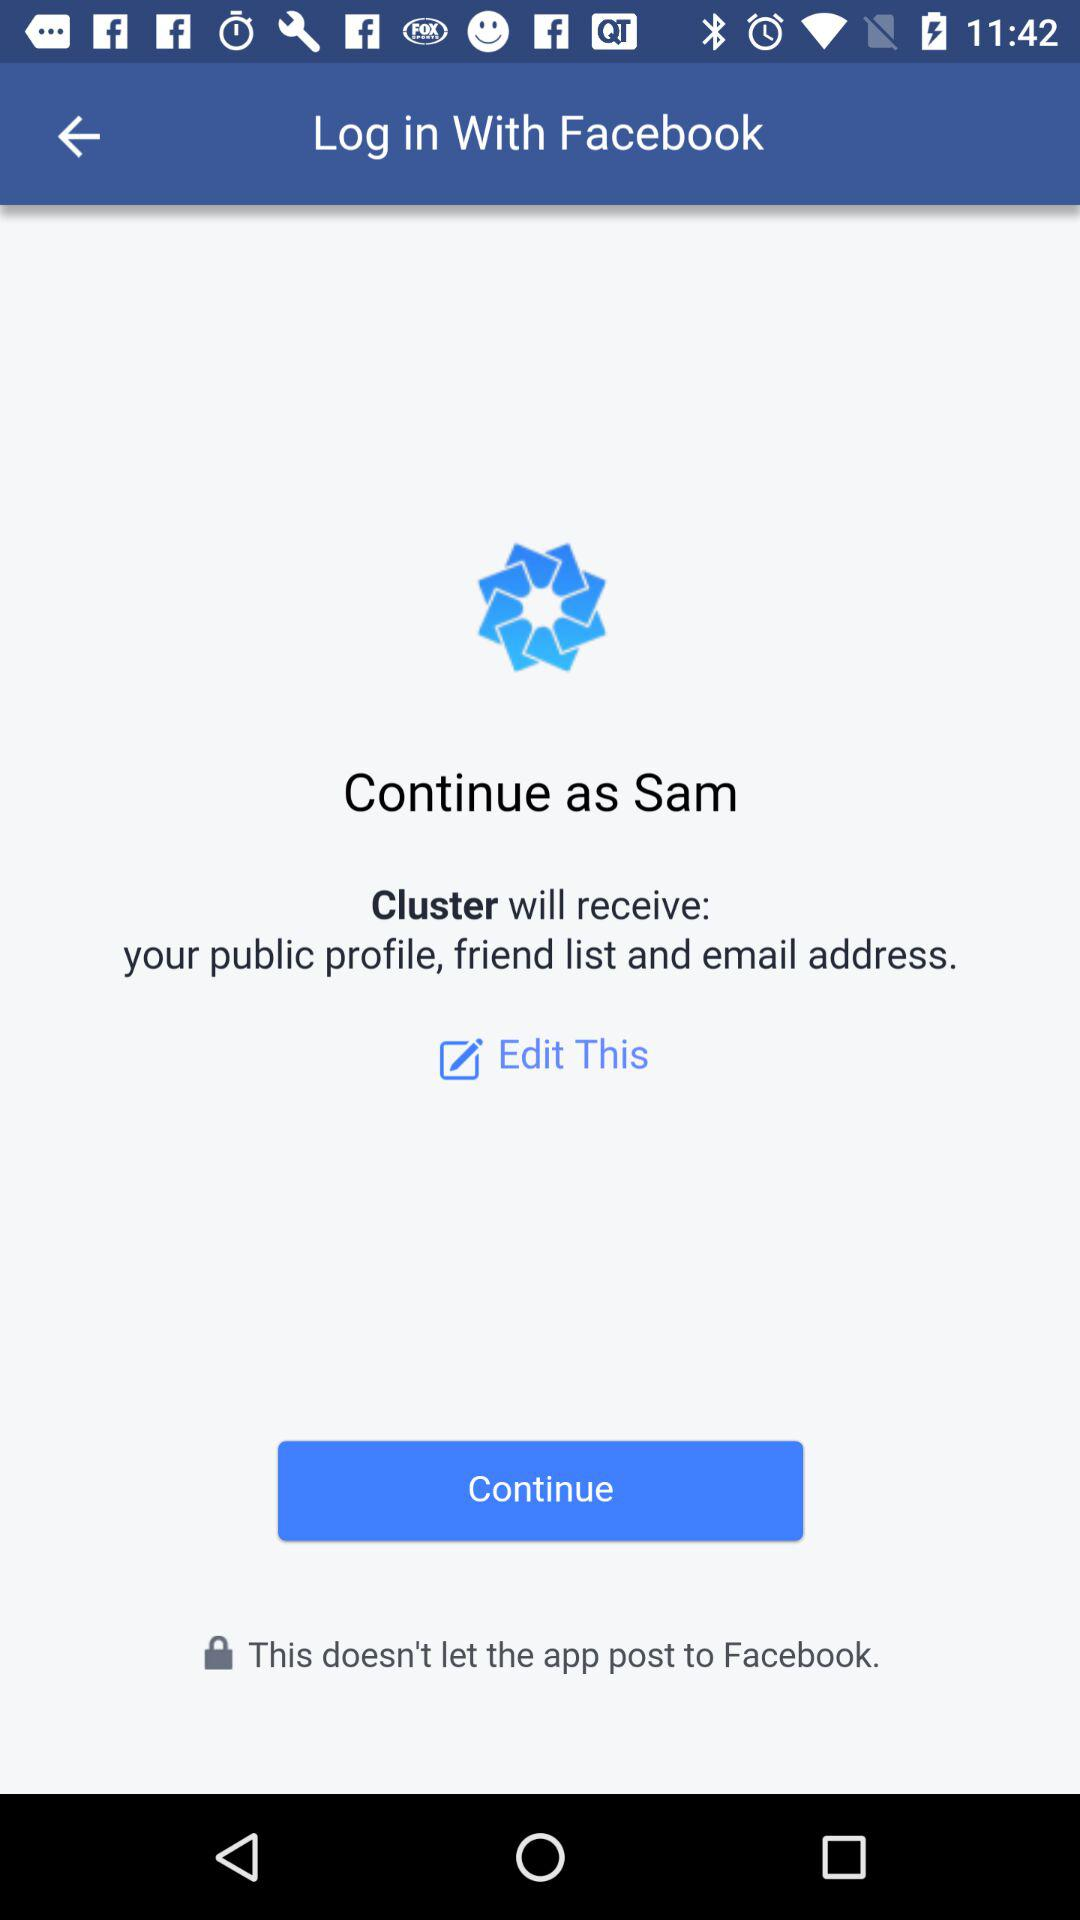What is the name of the application that can be used to log in? The name of the application that can be used to log in is "Facebook". 